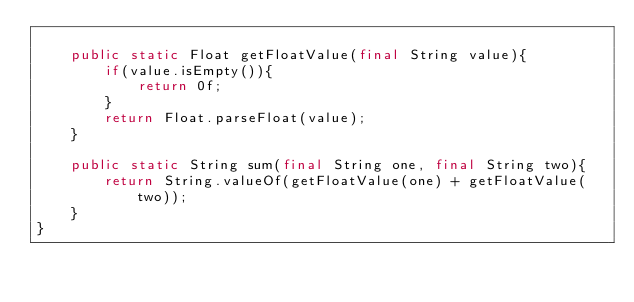Convert code to text. <code><loc_0><loc_0><loc_500><loc_500><_Java_>
    public static Float getFloatValue(final String value){
        if(value.isEmpty()){
            return 0f;
        }
        return Float.parseFloat(value);
    }

    public static String sum(final String one, final String two){
        return String.valueOf(getFloatValue(one) + getFloatValue(two));
    }
}
</code> 